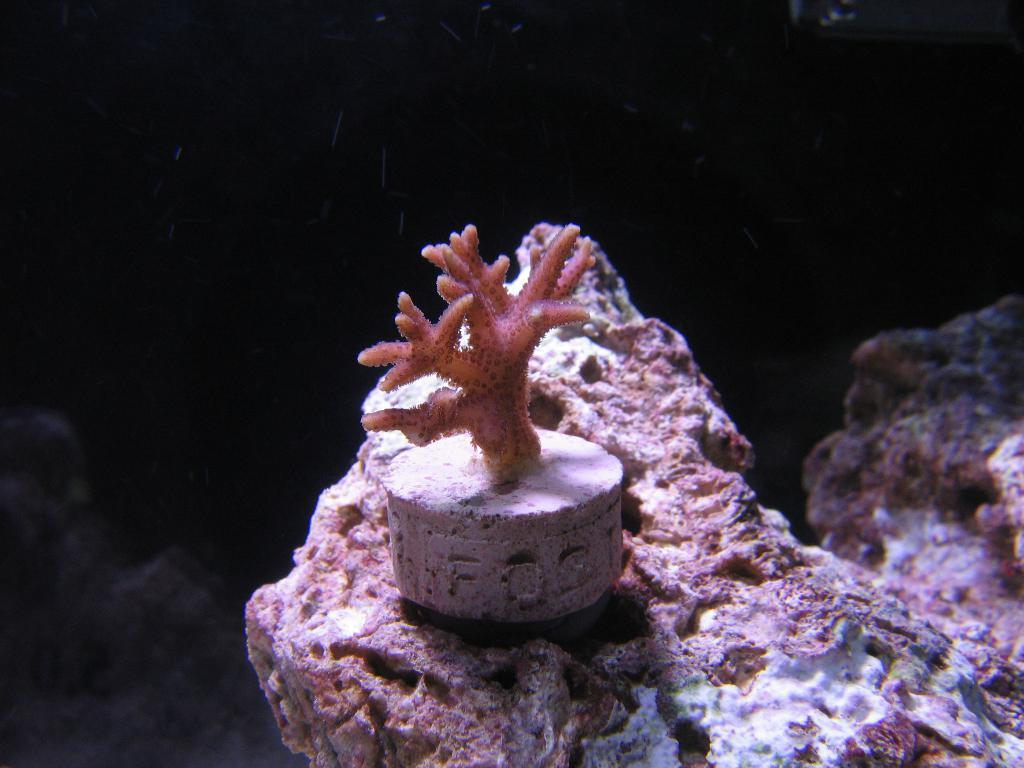What type of marine species is in the middle of the image? The specific marine species is not mentioned, but it is present in the middle of the image. What can be observed about the background of the image? The background of the image is dark. What is located at the bottom of the image? There is a rock at the bottom of the image. What type of butter is being used by the daughter in the image? There is no daughter or butter present in the image; it features a marine species and a dark background. 